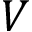Convert formula to latex. <formula><loc_0><loc_0><loc_500><loc_500>V</formula> 